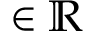Convert formula to latex. <formula><loc_0><loc_0><loc_500><loc_500>\in \mathbb { R }</formula> 